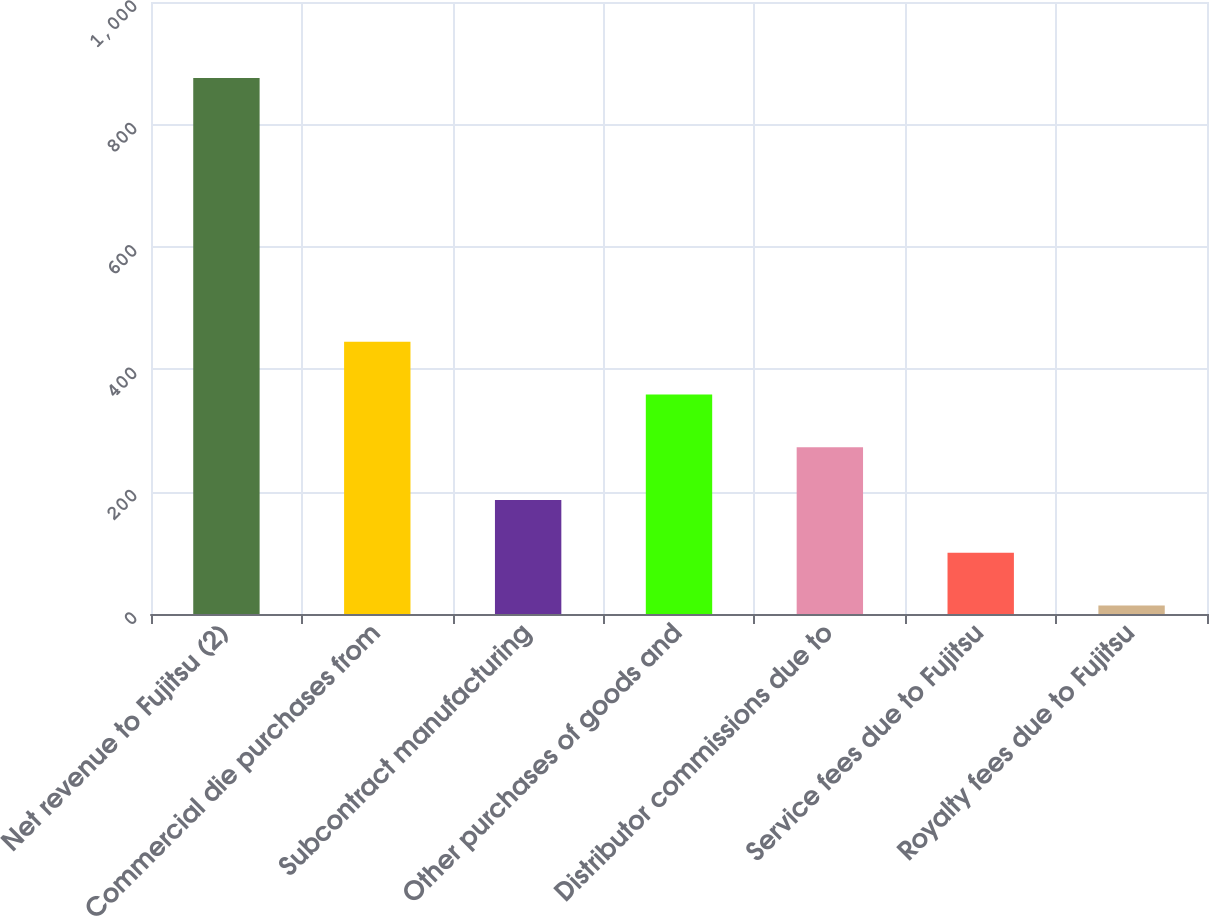Convert chart to OTSL. <chart><loc_0><loc_0><loc_500><loc_500><bar_chart><fcel>Net revenue to Fujitsu (2)<fcel>Commercial die purchases from<fcel>Subcontract manufacturing<fcel>Other purchases of goods and<fcel>Distributor commissions due to<fcel>Service fees due to Fujitsu<fcel>Royalty fees due to Fujitsu<nl><fcel>876<fcel>445<fcel>186.4<fcel>358.8<fcel>272.6<fcel>100.2<fcel>14<nl></chart> 